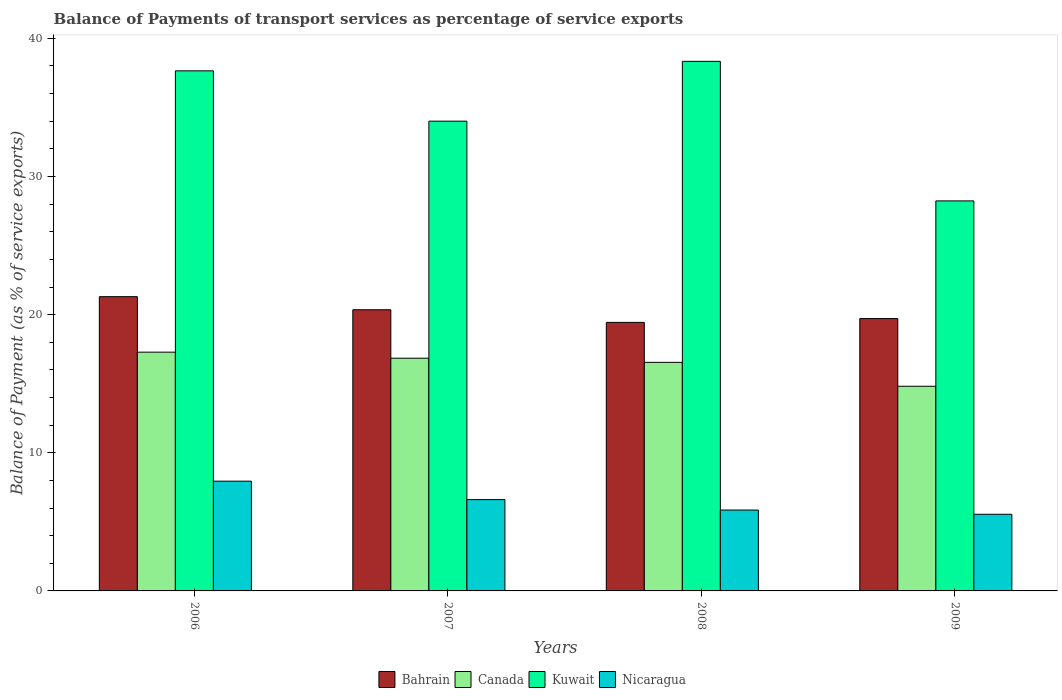How many bars are there on the 1st tick from the right?
Offer a very short reply. 4. In how many cases, is the number of bars for a given year not equal to the number of legend labels?
Your answer should be compact. 0. What is the balance of payments of transport services in Canada in 2009?
Keep it short and to the point. 14.82. Across all years, what is the maximum balance of payments of transport services in Nicaragua?
Your answer should be very brief. 7.95. Across all years, what is the minimum balance of payments of transport services in Nicaragua?
Provide a succinct answer. 5.55. What is the total balance of payments of transport services in Bahrain in the graph?
Your answer should be compact. 80.81. What is the difference between the balance of payments of transport services in Nicaragua in 2006 and that in 2008?
Give a very brief answer. 2.09. What is the difference between the balance of payments of transport services in Nicaragua in 2008 and the balance of payments of transport services in Kuwait in 2006?
Provide a short and direct response. -31.79. What is the average balance of payments of transport services in Nicaragua per year?
Your response must be concise. 6.49. In the year 2008, what is the difference between the balance of payments of transport services in Kuwait and balance of payments of transport services in Nicaragua?
Offer a terse response. 32.48. What is the ratio of the balance of payments of transport services in Bahrain in 2006 to that in 2009?
Offer a very short reply. 1.08. Is the balance of payments of transport services in Kuwait in 2006 less than that in 2008?
Your response must be concise. Yes. What is the difference between the highest and the second highest balance of payments of transport services in Bahrain?
Your response must be concise. 0.95. What is the difference between the highest and the lowest balance of payments of transport services in Nicaragua?
Offer a terse response. 2.4. Is the sum of the balance of payments of transport services in Canada in 2007 and 2009 greater than the maximum balance of payments of transport services in Kuwait across all years?
Your answer should be very brief. No. What does the 4th bar from the left in 2008 represents?
Offer a terse response. Nicaragua. What does the 4th bar from the right in 2007 represents?
Your response must be concise. Bahrain. What is the difference between two consecutive major ticks on the Y-axis?
Make the answer very short. 10. Are the values on the major ticks of Y-axis written in scientific E-notation?
Give a very brief answer. No. Does the graph contain grids?
Ensure brevity in your answer.  No. What is the title of the graph?
Keep it short and to the point. Balance of Payments of transport services as percentage of service exports. What is the label or title of the Y-axis?
Give a very brief answer. Balance of Payment (as % of service exports). What is the Balance of Payment (as % of service exports) in Bahrain in 2006?
Ensure brevity in your answer.  21.3. What is the Balance of Payment (as % of service exports) of Canada in 2006?
Offer a terse response. 17.28. What is the Balance of Payment (as % of service exports) in Kuwait in 2006?
Provide a succinct answer. 37.65. What is the Balance of Payment (as % of service exports) in Nicaragua in 2006?
Ensure brevity in your answer.  7.95. What is the Balance of Payment (as % of service exports) of Bahrain in 2007?
Your answer should be very brief. 20.35. What is the Balance of Payment (as % of service exports) in Canada in 2007?
Ensure brevity in your answer.  16.85. What is the Balance of Payment (as % of service exports) of Kuwait in 2007?
Give a very brief answer. 34.01. What is the Balance of Payment (as % of service exports) in Nicaragua in 2007?
Your response must be concise. 6.61. What is the Balance of Payment (as % of service exports) of Bahrain in 2008?
Give a very brief answer. 19.44. What is the Balance of Payment (as % of service exports) of Canada in 2008?
Provide a short and direct response. 16.55. What is the Balance of Payment (as % of service exports) in Kuwait in 2008?
Provide a succinct answer. 38.33. What is the Balance of Payment (as % of service exports) of Nicaragua in 2008?
Offer a very short reply. 5.85. What is the Balance of Payment (as % of service exports) of Bahrain in 2009?
Your response must be concise. 19.72. What is the Balance of Payment (as % of service exports) in Canada in 2009?
Ensure brevity in your answer.  14.82. What is the Balance of Payment (as % of service exports) of Kuwait in 2009?
Keep it short and to the point. 28.23. What is the Balance of Payment (as % of service exports) of Nicaragua in 2009?
Keep it short and to the point. 5.55. Across all years, what is the maximum Balance of Payment (as % of service exports) of Bahrain?
Your answer should be compact. 21.3. Across all years, what is the maximum Balance of Payment (as % of service exports) of Canada?
Ensure brevity in your answer.  17.28. Across all years, what is the maximum Balance of Payment (as % of service exports) in Kuwait?
Ensure brevity in your answer.  38.33. Across all years, what is the maximum Balance of Payment (as % of service exports) in Nicaragua?
Offer a terse response. 7.95. Across all years, what is the minimum Balance of Payment (as % of service exports) in Bahrain?
Offer a terse response. 19.44. Across all years, what is the minimum Balance of Payment (as % of service exports) in Canada?
Your answer should be very brief. 14.82. Across all years, what is the minimum Balance of Payment (as % of service exports) of Kuwait?
Ensure brevity in your answer.  28.23. Across all years, what is the minimum Balance of Payment (as % of service exports) of Nicaragua?
Keep it short and to the point. 5.55. What is the total Balance of Payment (as % of service exports) of Bahrain in the graph?
Your answer should be compact. 80.81. What is the total Balance of Payment (as % of service exports) in Canada in the graph?
Give a very brief answer. 65.49. What is the total Balance of Payment (as % of service exports) of Kuwait in the graph?
Ensure brevity in your answer.  138.22. What is the total Balance of Payment (as % of service exports) of Nicaragua in the graph?
Keep it short and to the point. 25.96. What is the difference between the Balance of Payment (as % of service exports) of Bahrain in 2006 and that in 2007?
Your answer should be very brief. 0.95. What is the difference between the Balance of Payment (as % of service exports) in Canada in 2006 and that in 2007?
Ensure brevity in your answer.  0.44. What is the difference between the Balance of Payment (as % of service exports) in Kuwait in 2006 and that in 2007?
Your response must be concise. 3.64. What is the difference between the Balance of Payment (as % of service exports) of Nicaragua in 2006 and that in 2007?
Your answer should be very brief. 1.33. What is the difference between the Balance of Payment (as % of service exports) in Bahrain in 2006 and that in 2008?
Make the answer very short. 1.86. What is the difference between the Balance of Payment (as % of service exports) of Canada in 2006 and that in 2008?
Offer a terse response. 0.74. What is the difference between the Balance of Payment (as % of service exports) in Kuwait in 2006 and that in 2008?
Give a very brief answer. -0.69. What is the difference between the Balance of Payment (as % of service exports) of Nicaragua in 2006 and that in 2008?
Make the answer very short. 2.09. What is the difference between the Balance of Payment (as % of service exports) in Bahrain in 2006 and that in 2009?
Provide a short and direct response. 1.59. What is the difference between the Balance of Payment (as % of service exports) of Canada in 2006 and that in 2009?
Your answer should be very brief. 2.47. What is the difference between the Balance of Payment (as % of service exports) of Kuwait in 2006 and that in 2009?
Your response must be concise. 9.42. What is the difference between the Balance of Payment (as % of service exports) in Nicaragua in 2006 and that in 2009?
Give a very brief answer. 2.4. What is the difference between the Balance of Payment (as % of service exports) of Bahrain in 2007 and that in 2008?
Your answer should be compact. 0.92. What is the difference between the Balance of Payment (as % of service exports) of Canada in 2007 and that in 2008?
Ensure brevity in your answer.  0.3. What is the difference between the Balance of Payment (as % of service exports) of Kuwait in 2007 and that in 2008?
Give a very brief answer. -4.33. What is the difference between the Balance of Payment (as % of service exports) of Nicaragua in 2007 and that in 2008?
Your response must be concise. 0.76. What is the difference between the Balance of Payment (as % of service exports) of Bahrain in 2007 and that in 2009?
Keep it short and to the point. 0.64. What is the difference between the Balance of Payment (as % of service exports) of Canada in 2007 and that in 2009?
Provide a short and direct response. 2.03. What is the difference between the Balance of Payment (as % of service exports) in Kuwait in 2007 and that in 2009?
Provide a succinct answer. 5.77. What is the difference between the Balance of Payment (as % of service exports) in Nicaragua in 2007 and that in 2009?
Your answer should be compact. 1.06. What is the difference between the Balance of Payment (as % of service exports) of Bahrain in 2008 and that in 2009?
Offer a terse response. -0.28. What is the difference between the Balance of Payment (as % of service exports) in Canada in 2008 and that in 2009?
Your response must be concise. 1.73. What is the difference between the Balance of Payment (as % of service exports) in Kuwait in 2008 and that in 2009?
Provide a succinct answer. 10.1. What is the difference between the Balance of Payment (as % of service exports) of Nicaragua in 2008 and that in 2009?
Offer a terse response. 0.31. What is the difference between the Balance of Payment (as % of service exports) of Bahrain in 2006 and the Balance of Payment (as % of service exports) of Canada in 2007?
Your answer should be very brief. 4.45. What is the difference between the Balance of Payment (as % of service exports) in Bahrain in 2006 and the Balance of Payment (as % of service exports) in Kuwait in 2007?
Keep it short and to the point. -12.7. What is the difference between the Balance of Payment (as % of service exports) of Bahrain in 2006 and the Balance of Payment (as % of service exports) of Nicaragua in 2007?
Your answer should be very brief. 14.69. What is the difference between the Balance of Payment (as % of service exports) in Canada in 2006 and the Balance of Payment (as % of service exports) in Kuwait in 2007?
Make the answer very short. -16.72. What is the difference between the Balance of Payment (as % of service exports) in Canada in 2006 and the Balance of Payment (as % of service exports) in Nicaragua in 2007?
Offer a terse response. 10.67. What is the difference between the Balance of Payment (as % of service exports) of Kuwait in 2006 and the Balance of Payment (as % of service exports) of Nicaragua in 2007?
Offer a terse response. 31.04. What is the difference between the Balance of Payment (as % of service exports) of Bahrain in 2006 and the Balance of Payment (as % of service exports) of Canada in 2008?
Offer a terse response. 4.76. What is the difference between the Balance of Payment (as % of service exports) in Bahrain in 2006 and the Balance of Payment (as % of service exports) in Kuwait in 2008?
Ensure brevity in your answer.  -17.03. What is the difference between the Balance of Payment (as % of service exports) in Bahrain in 2006 and the Balance of Payment (as % of service exports) in Nicaragua in 2008?
Offer a very short reply. 15.45. What is the difference between the Balance of Payment (as % of service exports) of Canada in 2006 and the Balance of Payment (as % of service exports) of Kuwait in 2008?
Your answer should be compact. -21.05. What is the difference between the Balance of Payment (as % of service exports) of Canada in 2006 and the Balance of Payment (as % of service exports) of Nicaragua in 2008?
Your answer should be compact. 11.43. What is the difference between the Balance of Payment (as % of service exports) in Kuwait in 2006 and the Balance of Payment (as % of service exports) in Nicaragua in 2008?
Your response must be concise. 31.79. What is the difference between the Balance of Payment (as % of service exports) of Bahrain in 2006 and the Balance of Payment (as % of service exports) of Canada in 2009?
Your answer should be very brief. 6.49. What is the difference between the Balance of Payment (as % of service exports) in Bahrain in 2006 and the Balance of Payment (as % of service exports) in Kuwait in 2009?
Provide a short and direct response. -6.93. What is the difference between the Balance of Payment (as % of service exports) in Bahrain in 2006 and the Balance of Payment (as % of service exports) in Nicaragua in 2009?
Your response must be concise. 15.75. What is the difference between the Balance of Payment (as % of service exports) in Canada in 2006 and the Balance of Payment (as % of service exports) in Kuwait in 2009?
Give a very brief answer. -10.95. What is the difference between the Balance of Payment (as % of service exports) in Canada in 2006 and the Balance of Payment (as % of service exports) in Nicaragua in 2009?
Offer a very short reply. 11.74. What is the difference between the Balance of Payment (as % of service exports) of Kuwait in 2006 and the Balance of Payment (as % of service exports) of Nicaragua in 2009?
Provide a succinct answer. 32.1. What is the difference between the Balance of Payment (as % of service exports) in Bahrain in 2007 and the Balance of Payment (as % of service exports) in Canada in 2008?
Provide a short and direct response. 3.81. What is the difference between the Balance of Payment (as % of service exports) of Bahrain in 2007 and the Balance of Payment (as % of service exports) of Kuwait in 2008?
Your response must be concise. -17.98. What is the difference between the Balance of Payment (as % of service exports) in Bahrain in 2007 and the Balance of Payment (as % of service exports) in Nicaragua in 2008?
Provide a short and direct response. 14.5. What is the difference between the Balance of Payment (as % of service exports) of Canada in 2007 and the Balance of Payment (as % of service exports) of Kuwait in 2008?
Keep it short and to the point. -21.49. What is the difference between the Balance of Payment (as % of service exports) in Canada in 2007 and the Balance of Payment (as % of service exports) in Nicaragua in 2008?
Your answer should be very brief. 10.99. What is the difference between the Balance of Payment (as % of service exports) in Kuwait in 2007 and the Balance of Payment (as % of service exports) in Nicaragua in 2008?
Provide a short and direct response. 28.15. What is the difference between the Balance of Payment (as % of service exports) of Bahrain in 2007 and the Balance of Payment (as % of service exports) of Canada in 2009?
Provide a short and direct response. 5.54. What is the difference between the Balance of Payment (as % of service exports) of Bahrain in 2007 and the Balance of Payment (as % of service exports) of Kuwait in 2009?
Offer a terse response. -7.88. What is the difference between the Balance of Payment (as % of service exports) of Bahrain in 2007 and the Balance of Payment (as % of service exports) of Nicaragua in 2009?
Your answer should be compact. 14.81. What is the difference between the Balance of Payment (as % of service exports) in Canada in 2007 and the Balance of Payment (as % of service exports) in Kuwait in 2009?
Ensure brevity in your answer.  -11.39. What is the difference between the Balance of Payment (as % of service exports) of Canada in 2007 and the Balance of Payment (as % of service exports) of Nicaragua in 2009?
Your answer should be compact. 11.3. What is the difference between the Balance of Payment (as % of service exports) of Kuwait in 2007 and the Balance of Payment (as % of service exports) of Nicaragua in 2009?
Your answer should be very brief. 28.46. What is the difference between the Balance of Payment (as % of service exports) in Bahrain in 2008 and the Balance of Payment (as % of service exports) in Canada in 2009?
Keep it short and to the point. 4.62. What is the difference between the Balance of Payment (as % of service exports) in Bahrain in 2008 and the Balance of Payment (as % of service exports) in Kuwait in 2009?
Your response must be concise. -8.79. What is the difference between the Balance of Payment (as % of service exports) in Bahrain in 2008 and the Balance of Payment (as % of service exports) in Nicaragua in 2009?
Your answer should be compact. 13.89. What is the difference between the Balance of Payment (as % of service exports) in Canada in 2008 and the Balance of Payment (as % of service exports) in Kuwait in 2009?
Make the answer very short. -11.69. What is the difference between the Balance of Payment (as % of service exports) of Canada in 2008 and the Balance of Payment (as % of service exports) of Nicaragua in 2009?
Make the answer very short. 11. What is the difference between the Balance of Payment (as % of service exports) in Kuwait in 2008 and the Balance of Payment (as % of service exports) in Nicaragua in 2009?
Your answer should be compact. 32.79. What is the average Balance of Payment (as % of service exports) of Bahrain per year?
Your answer should be compact. 20.2. What is the average Balance of Payment (as % of service exports) of Canada per year?
Your answer should be very brief. 16.37. What is the average Balance of Payment (as % of service exports) of Kuwait per year?
Your answer should be very brief. 34.56. What is the average Balance of Payment (as % of service exports) in Nicaragua per year?
Provide a succinct answer. 6.49. In the year 2006, what is the difference between the Balance of Payment (as % of service exports) of Bahrain and Balance of Payment (as % of service exports) of Canada?
Offer a terse response. 4.02. In the year 2006, what is the difference between the Balance of Payment (as % of service exports) of Bahrain and Balance of Payment (as % of service exports) of Kuwait?
Offer a terse response. -16.35. In the year 2006, what is the difference between the Balance of Payment (as % of service exports) in Bahrain and Balance of Payment (as % of service exports) in Nicaragua?
Provide a short and direct response. 13.36. In the year 2006, what is the difference between the Balance of Payment (as % of service exports) in Canada and Balance of Payment (as % of service exports) in Kuwait?
Provide a short and direct response. -20.36. In the year 2006, what is the difference between the Balance of Payment (as % of service exports) of Canada and Balance of Payment (as % of service exports) of Nicaragua?
Provide a short and direct response. 9.34. In the year 2006, what is the difference between the Balance of Payment (as % of service exports) in Kuwait and Balance of Payment (as % of service exports) in Nicaragua?
Provide a short and direct response. 29.7. In the year 2007, what is the difference between the Balance of Payment (as % of service exports) of Bahrain and Balance of Payment (as % of service exports) of Canada?
Offer a terse response. 3.51. In the year 2007, what is the difference between the Balance of Payment (as % of service exports) in Bahrain and Balance of Payment (as % of service exports) in Kuwait?
Your answer should be compact. -13.65. In the year 2007, what is the difference between the Balance of Payment (as % of service exports) in Bahrain and Balance of Payment (as % of service exports) in Nicaragua?
Provide a succinct answer. 13.74. In the year 2007, what is the difference between the Balance of Payment (as % of service exports) in Canada and Balance of Payment (as % of service exports) in Kuwait?
Provide a short and direct response. -17.16. In the year 2007, what is the difference between the Balance of Payment (as % of service exports) in Canada and Balance of Payment (as % of service exports) in Nicaragua?
Offer a terse response. 10.24. In the year 2007, what is the difference between the Balance of Payment (as % of service exports) of Kuwait and Balance of Payment (as % of service exports) of Nicaragua?
Make the answer very short. 27.4. In the year 2008, what is the difference between the Balance of Payment (as % of service exports) of Bahrain and Balance of Payment (as % of service exports) of Canada?
Give a very brief answer. 2.89. In the year 2008, what is the difference between the Balance of Payment (as % of service exports) of Bahrain and Balance of Payment (as % of service exports) of Kuwait?
Give a very brief answer. -18.9. In the year 2008, what is the difference between the Balance of Payment (as % of service exports) in Bahrain and Balance of Payment (as % of service exports) in Nicaragua?
Your answer should be very brief. 13.58. In the year 2008, what is the difference between the Balance of Payment (as % of service exports) of Canada and Balance of Payment (as % of service exports) of Kuwait?
Offer a very short reply. -21.79. In the year 2008, what is the difference between the Balance of Payment (as % of service exports) in Canada and Balance of Payment (as % of service exports) in Nicaragua?
Your response must be concise. 10.69. In the year 2008, what is the difference between the Balance of Payment (as % of service exports) of Kuwait and Balance of Payment (as % of service exports) of Nicaragua?
Your answer should be compact. 32.48. In the year 2009, what is the difference between the Balance of Payment (as % of service exports) in Bahrain and Balance of Payment (as % of service exports) in Canada?
Your response must be concise. 4.9. In the year 2009, what is the difference between the Balance of Payment (as % of service exports) in Bahrain and Balance of Payment (as % of service exports) in Kuwait?
Keep it short and to the point. -8.52. In the year 2009, what is the difference between the Balance of Payment (as % of service exports) in Bahrain and Balance of Payment (as % of service exports) in Nicaragua?
Your answer should be very brief. 14.17. In the year 2009, what is the difference between the Balance of Payment (as % of service exports) in Canada and Balance of Payment (as % of service exports) in Kuwait?
Keep it short and to the point. -13.42. In the year 2009, what is the difference between the Balance of Payment (as % of service exports) in Canada and Balance of Payment (as % of service exports) in Nicaragua?
Your answer should be very brief. 9.27. In the year 2009, what is the difference between the Balance of Payment (as % of service exports) of Kuwait and Balance of Payment (as % of service exports) of Nicaragua?
Your answer should be very brief. 22.68. What is the ratio of the Balance of Payment (as % of service exports) of Bahrain in 2006 to that in 2007?
Offer a terse response. 1.05. What is the ratio of the Balance of Payment (as % of service exports) of Canada in 2006 to that in 2007?
Ensure brevity in your answer.  1.03. What is the ratio of the Balance of Payment (as % of service exports) in Kuwait in 2006 to that in 2007?
Ensure brevity in your answer.  1.11. What is the ratio of the Balance of Payment (as % of service exports) in Nicaragua in 2006 to that in 2007?
Make the answer very short. 1.2. What is the ratio of the Balance of Payment (as % of service exports) of Bahrain in 2006 to that in 2008?
Provide a short and direct response. 1.1. What is the ratio of the Balance of Payment (as % of service exports) in Canada in 2006 to that in 2008?
Make the answer very short. 1.04. What is the ratio of the Balance of Payment (as % of service exports) in Kuwait in 2006 to that in 2008?
Your answer should be compact. 0.98. What is the ratio of the Balance of Payment (as % of service exports) of Nicaragua in 2006 to that in 2008?
Offer a very short reply. 1.36. What is the ratio of the Balance of Payment (as % of service exports) in Bahrain in 2006 to that in 2009?
Your answer should be very brief. 1.08. What is the ratio of the Balance of Payment (as % of service exports) in Canada in 2006 to that in 2009?
Offer a terse response. 1.17. What is the ratio of the Balance of Payment (as % of service exports) in Kuwait in 2006 to that in 2009?
Your response must be concise. 1.33. What is the ratio of the Balance of Payment (as % of service exports) of Nicaragua in 2006 to that in 2009?
Your response must be concise. 1.43. What is the ratio of the Balance of Payment (as % of service exports) of Bahrain in 2007 to that in 2008?
Provide a succinct answer. 1.05. What is the ratio of the Balance of Payment (as % of service exports) in Canada in 2007 to that in 2008?
Offer a very short reply. 1.02. What is the ratio of the Balance of Payment (as % of service exports) in Kuwait in 2007 to that in 2008?
Offer a very short reply. 0.89. What is the ratio of the Balance of Payment (as % of service exports) of Nicaragua in 2007 to that in 2008?
Offer a very short reply. 1.13. What is the ratio of the Balance of Payment (as % of service exports) of Bahrain in 2007 to that in 2009?
Keep it short and to the point. 1.03. What is the ratio of the Balance of Payment (as % of service exports) of Canada in 2007 to that in 2009?
Your answer should be compact. 1.14. What is the ratio of the Balance of Payment (as % of service exports) in Kuwait in 2007 to that in 2009?
Make the answer very short. 1.2. What is the ratio of the Balance of Payment (as % of service exports) in Nicaragua in 2007 to that in 2009?
Your response must be concise. 1.19. What is the ratio of the Balance of Payment (as % of service exports) in Bahrain in 2008 to that in 2009?
Ensure brevity in your answer.  0.99. What is the ratio of the Balance of Payment (as % of service exports) in Canada in 2008 to that in 2009?
Your response must be concise. 1.12. What is the ratio of the Balance of Payment (as % of service exports) in Kuwait in 2008 to that in 2009?
Give a very brief answer. 1.36. What is the ratio of the Balance of Payment (as % of service exports) of Nicaragua in 2008 to that in 2009?
Your answer should be compact. 1.06. What is the difference between the highest and the second highest Balance of Payment (as % of service exports) of Bahrain?
Your answer should be very brief. 0.95. What is the difference between the highest and the second highest Balance of Payment (as % of service exports) of Canada?
Provide a succinct answer. 0.44. What is the difference between the highest and the second highest Balance of Payment (as % of service exports) of Kuwait?
Your response must be concise. 0.69. What is the difference between the highest and the second highest Balance of Payment (as % of service exports) in Nicaragua?
Your response must be concise. 1.33. What is the difference between the highest and the lowest Balance of Payment (as % of service exports) in Bahrain?
Your response must be concise. 1.86. What is the difference between the highest and the lowest Balance of Payment (as % of service exports) of Canada?
Provide a succinct answer. 2.47. What is the difference between the highest and the lowest Balance of Payment (as % of service exports) of Kuwait?
Offer a very short reply. 10.1. What is the difference between the highest and the lowest Balance of Payment (as % of service exports) in Nicaragua?
Your response must be concise. 2.4. 